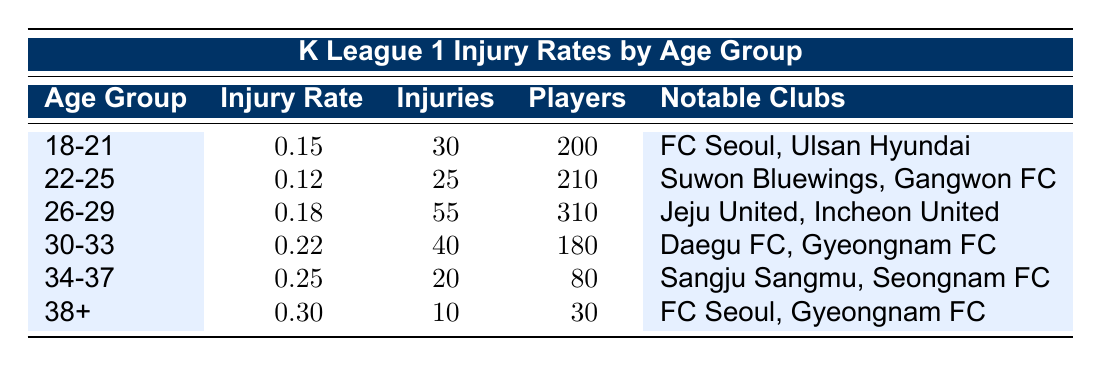What is the injury rate for players aged 22-25? The injury rate for the age group of 22-25 is provided directly in the table under the "Injury Rate" column corresponding to that age group. It shows a value of 0.12.
Answer: 0.12 How many total players are there in the age group 30-33? The table indicates the total player count for the age group 30-33 in the "Players" column, which records the number as 180.
Answer: 180 Which age group has the highest number of injuries? By reviewing the "Injuries" column, we find that the age group 26-29 has the highest number of injuries recorded at 55.
Answer: 26-29 What is the average injury rate across all age groups? To find the average, we first add the injury rates: (0.15 + 0.12 + 0.18 + 0.22 + 0.25 + 0.30) = 1.12. Then, we divide by the total number of age groups, which is 6: 1.12/6 = 0.1867.
Answer: 0.19 Are there any age groups where the injury rate exceeds 0.25? By checking the "Injury Rate" column across all age groups, we see that only the age group 34-37 has an injury rate of exactly 0.25, while the 38+ group exceeds it at 0.30. Thus, the statement is true.
Answer: Yes What is the total number of players for age groups 34-37 and 38+ combined? First, we find the total number of players in both age groups from the "Players" column: 80 (for 34-37) + 30 (for 38+) = 110.
Answer: 110 In which age group do clubs like Jeju United and Incheon United belong? By consulting the "Notable Clubs" column, we find that Jeju United and Incheon United are mentioned in the age group 26-29.
Answer: 26-29 Is the injury rate for the age group 18-21 lower than that for the age group 22-25? By comparing the injury rates, we see that 0.15 (for 18-21) is greater than 0.12 (for 22-25), so the statement is false.
Answer: No What is the difference in injury rates between the youngest age group and the oldest age group? The injury rate for the youngest age group is 0.15 and for the oldest age group, it is 0.30. The difference is calculated as 0.30 - 0.15 = 0.15.
Answer: 0.15 